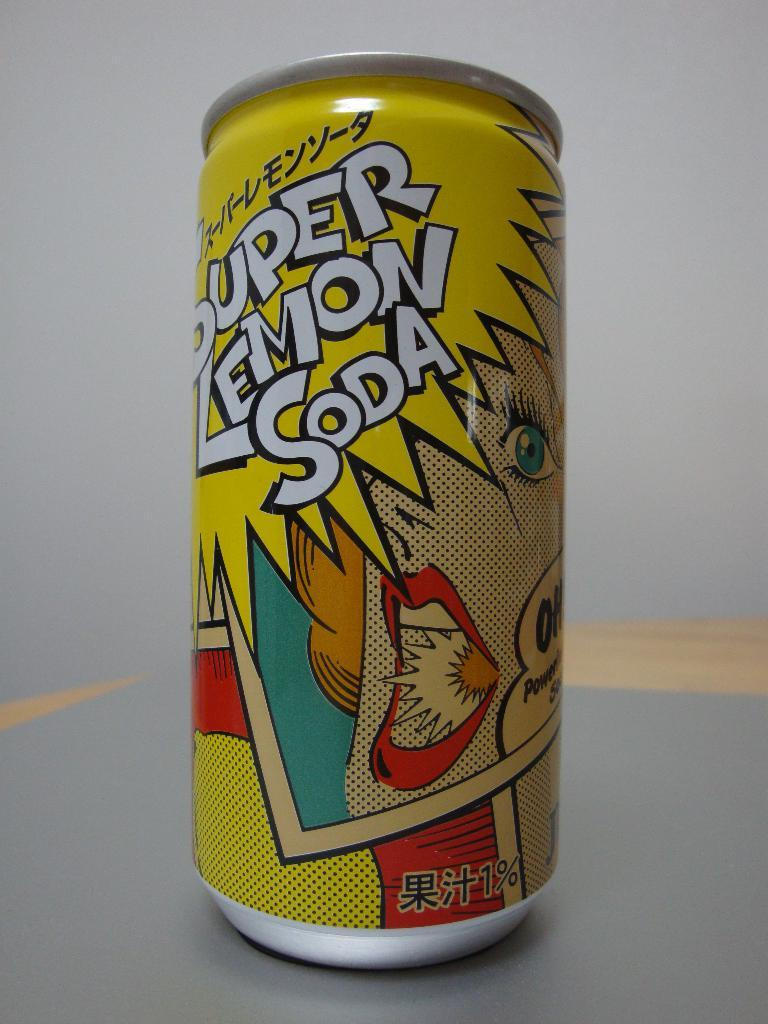<image>
Create a compact narrative representing the image presented. A can of Super Lemon Soda sits atop a counter. 